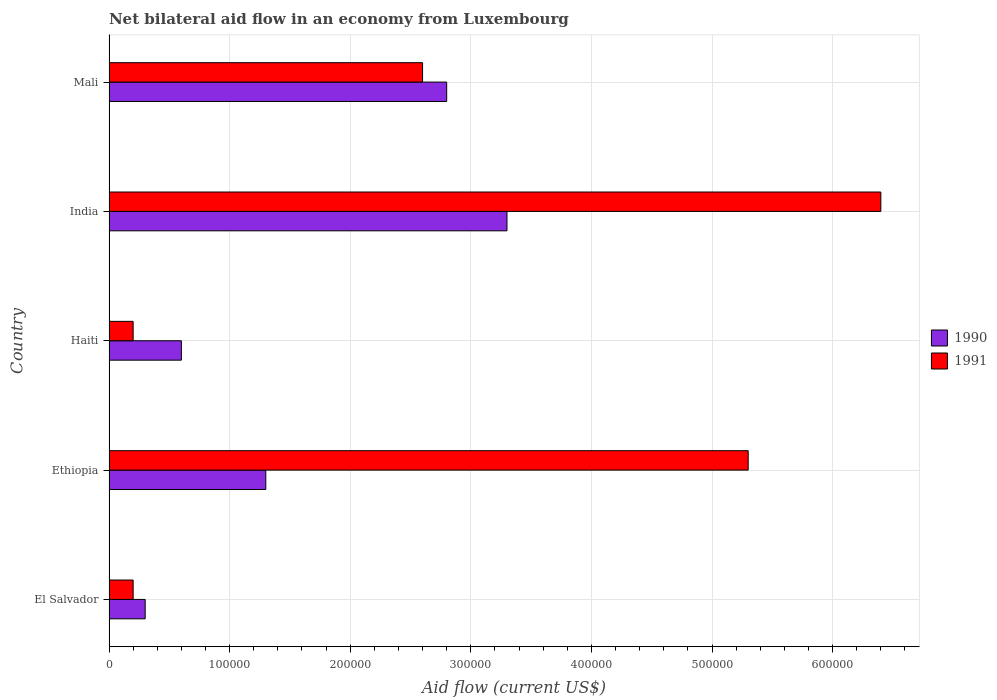How many bars are there on the 5th tick from the top?
Give a very brief answer. 2. What is the label of the 4th group of bars from the top?
Keep it short and to the point. Ethiopia. In how many cases, is the number of bars for a given country not equal to the number of legend labels?
Make the answer very short. 0. What is the net bilateral aid flow in 1990 in Ethiopia?
Ensure brevity in your answer.  1.30e+05. Across all countries, what is the maximum net bilateral aid flow in 1991?
Provide a short and direct response. 6.40e+05. Across all countries, what is the minimum net bilateral aid flow in 1991?
Keep it short and to the point. 2.00e+04. In which country was the net bilateral aid flow in 1991 minimum?
Offer a very short reply. El Salvador. What is the total net bilateral aid flow in 1991 in the graph?
Make the answer very short. 1.47e+06. What is the difference between the net bilateral aid flow in 1991 in Ethiopia and that in India?
Provide a succinct answer. -1.10e+05. What is the average net bilateral aid flow in 1990 per country?
Ensure brevity in your answer.  1.66e+05. What is the difference between the net bilateral aid flow in 1991 and net bilateral aid flow in 1990 in Mali?
Provide a succinct answer. -2.00e+04. In how many countries, is the net bilateral aid flow in 1990 greater than 540000 US$?
Offer a terse response. 0. What is the ratio of the net bilateral aid flow in 1991 in Haiti to that in India?
Make the answer very short. 0.03. Is the net bilateral aid flow in 1991 in El Salvador less than that in Ethiopia?
Offer a very short reply. Yes. Is the difference between the net bilateral aid flow in 1991 in El Salvador and India greater than the difference between the net bilateral aid flow in 1990 in El Salvador and India?
Make the answer very short. No. What is the difference between the highest and the second highest net bilateral aid flow in 1991?
Your answer should be compact. 1.10e+05. What is the difference between the highest and the lowest net bilateral aid flow in 1991?
Ensure brevity in your answer.  6.20e+05. In how many countries, is the net bilateral aid flow in 1991 greater than the average net bilateral aid flow in 1991 taken over all countries?
Offer a very short reply. 2. What does the 1st bar from the top in India represents?
Give a very brief answer. 1991. What does the 2nd bar from the bottom in India represents?
Your answer should be very brief. 1991. How many bars are there?
Ensure brevity in your answer.  10. How many countries are there in the graph?
Ensure brevity in your answer.  5. What is the difference between two consecutive major ticks on the X-axis?
Offer a terse response. 1.00e+05. How are the legend labels stacked?
Offer a terse response. Vertical. What is the title of the graph?
Provide a short and direct response. Net bilateral aid flow in an economy from Luxembourg. What is the label or title of the X-axis?
Offer a terse response. Aid flow (current US$). What is the Aid flow (current US$) of 1990 in El Salvador?
Ensure brevity in your answer.  3.00e+04. What is the Aid flow (current US$) of 1991 in El Salvador?
Provide a succinct answer. 2.00e+04. What is the Aid flow (current US$) of 1990 in Ethiopia?
Your response must be concise. 1.30e+05. What is the Aid flow (current US$) of 1991 in Ethiopia?
Offer a very short reply. 5.30e+05. What is the Aid flow (current US$) of 1991 in Haiti?
Your response must be concise. 2.00e+04. What is the Aid flow (current US$) of 1990 in India?
Provide a short and direct response. 3.30e+05. What is the Aid flow (current US$) in 1991 in India?
Your answer should be very brief. 6.40e+05. What is the Aid flow (current US$) of 1991 in Mali?
Ensure brevity in your answer.  2.60e+05. Across all countries, what is the maximum Aid flow (current US$) of 1991?
Ensure brevity in your answer.  6.40e+05. Across all countries, what is the minimum Aid flow (current US$) of 1991?
Your answer should be compact. 2.00e+04. What is the total Aid flow (current US$) in 1990 in the graph?
Make the answer very short. 8.30e+05. What is the total Aid flow (current US$) of 1991 in the graph?
Your answer should be compact. 1.47e+06. What is the difference between the Aid flow (current US$) of 1990 in El Salvador and that in Ethiopia?
Offer a very short reply. -1.00e+05. What is the difference between the Aid flow (current US$) of 1991 in El Salvador and that in Ethiopia?
Ensure brevity in your answer.  -5.10e+05. What is the difference between the Aid flow (current US$) of 1990 in El Salvador and that in Haiti?
Provide a succinct answer. -3.00e+04. What is the difference between the Aid flow (current US$) in 1991 in El Salvador and that in India?
Make the answer very short. -6.20e+05. What is the difference between the Aid flow (current US$) in 1991 in El Salvador and that in Mali?
Offer a very short reply. -2.40e+05. What is the difference between the Aid flow (current US$) in 1990 in Ethiopia and that in Haiti?
Your response must be concise. 7.00e+04. What is the difference between the Aid flow (current US$) of 1991 in Ethiopia and that in Haiti?
Provide a succinct answer. 5.10e+05. What is the difference between the Aid flow (current US$) of 1990 in Ethiopia and that in Mali?
Offer a terse response. -1.50e+05. What is the difference between the Aid flow (current US$) in 1991 in Ethiopia and that in Mali?
Keep it short and to the point. 2.70e+05. What is the difference between the Aid flow (current US$) in 1991 in Haiti and that in India?
Offer a terse response. -6.20e+05. What is the difference between the Aid flow (current US$) in 1990 in Haiti and that in Mali?
Provide a succinct answer. -2.20e+05. What is the difference between the Aid flow (current US$) in 1990 in India and that in Mali?
Your answer should be very brief. 5.00e+04. What is the difference between the Aid flow (current US$) of 1991 in India and that in Mali?
Provide a short and direct response. 3.80e+05. What is the difference between the Aid flow (current US$) in 1990 in El Salvador and the Aid flow (current US$) in 1991 in Ethiopia?
Your response must be concise. -5.00e+05. What is the difference between the Aid flow (current US$) in 1990 in El Salvador and the Aid flow (current US$) in 1991 in Haiti?
Offer a very short reply. 10000. What is the difference between the Aid flow (current US$) of 1990 in El Salvador and the Aid flow (current US$) of 1991 in India?
Ensure brevity in your answer.  -6.10e+05. What is the difference between the Aid flow (current US$) in 1990 in Ethiopia and the Aid flow (current US$) in 1991 in Haiti?
Give a very brief answer. 1.10e+05. What is the difference between the Aid flow (current US$) in 1990 in Ethiopia and the Aid flow (current US$) in 1991 in India?
Your response must be concise. -5.10e+05. What is the difference between the Aid flow (current US$) of 1990 in Haiti and the Aid flow (current US$) of 1991 in India?
Your answer should be compact. -5.80e+05. What is the average Aid flow (current US$) of 1990 per country?
Give a very brief answer. 1.66e+05. What is the average Aid flow (current US$) of 1991 per country?
Make the answer very short. 2.94e+05. What is the difference between the Aid flow (current US$) of 1990 and Aid flow (current US$) of 1991 in Ethiopia?
Your answer should be very brief. -4.00e+05. What is the difference between the Aid flow (current US$) of 1990 and Aid flow (current US$) of 1991 in Haiti?
Provide a short and direct response. 4.00e+04. What is the difference between the Aid flow (current US$) of 1990 and Aid flow (current US$) of 1991 in India?
Your answer should be very brief. -3.10e+05. What is the difference between the Aid flow (current US$) in 1990 and Aid flow (current US$) in 1991 in Mali?
Provide a short and direct response. 2.00e+04. What is the ratio of the Aid flow (current US$) of 1990 in El Salvador to that in Ethiopia?
Give a very brief answer. 0.23. What is the ratio of the Aid flow (current US$) of 1991 in El Salvador to that in Ethiopia?
Make the answer very short. 0.04. What is the ratio of the Aid flow (current US$) in 1990 in El Salvador to that in India?
Offer a very short reply. 0.09. What is the ratio of the Aid flow (current US$) of 1991 in El Salvador to that in India?
Give a very brief answer. 0.03. What is the ratio of the Aid flow (current US$) of 1990 in El Salvador to that in Mali?
Your response must be concise. 0.11. What is the ratio of the Aid flow (current US$) in 1991 in El Salvador to that in Mali?
Your answer should be compact. 0.08. What is the ratio of the Aid flow (current US$) in 1990 in Ethiopia to that in Haiti?
Offer a terse response. 2.17. What is the ratio of the Aid flow (current US$) of 1991 in Ethiopia to that in Haiti?
Make the answer very short. 26.5. What is the ratio of the Aid flow (current US$) in 1990 in Ethiopia to that in India?
Your answer should be compact. 0.39. What is the ratio of the Aid flow (current US$) in 1991 in Ethiopia to that in India?
Offer a terse response. 0.83. What is the ratio of the Aid flow (current US$) in 1990 in Ethiopia to that in Mali?
Your answer should be very brief. 0.46. What is the ratio of the Aid flow (current US$) in 1991 in Ethiopia to that in Mali?
Your answer should be very brief. 2.04. What is the ratio of the Aid flow (current US$) of 1990 in Haiti to that in India?
Give a very brief answer. 0.18. What is the ratio of the Aid flow (current US$) in 1991 in Haiti to that in India?
Ensure brevity in your answer.  0.03. What is the ratio of the Aid flow (current US$) in 1990 in Haiti to that in Mali?
Offer a very short reply. 0.21. What is the ratio of the Aid flow (current US$) of 1991 in Haiti to that in Mali?
Keep it short and to the point. 0.08. What is the ratio of the Aid flow (current US$) in 1990 in India to that in Mali?
Your response must be concise. 1.18. What is the ratio of the Aid flow (current US$) of 1991 in India to that in Mali?
Provide a short and direct response. 2.46. What is the difference between the highest and the second highest Aid flow (current US$) of 1990?
Your answer should be very brief. 5.00e+04. What is the difference between the highest and the second highest Aid flow (current US$) in 1991?
Offer a terse response. 1.10e+05. What is the difference between the highest and the lowest Aid flow (current US$) in 1990?
Keep it short and to the point. 3.00e+05. What is the difference between the highest and the lowest Aid flow (current US$) of 1991?
Give a very brief answer. 6.20e+05. 